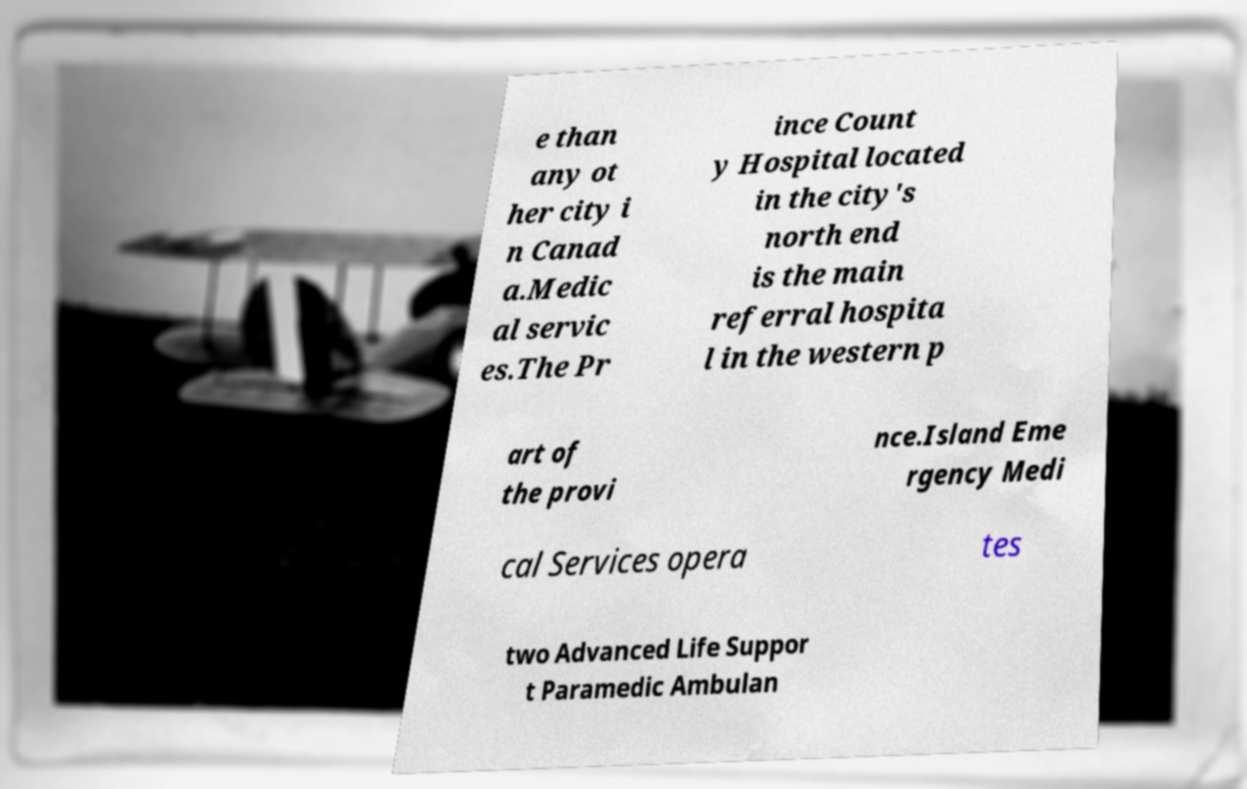Can you read and provide the text displayed in the image?This photo seems to have some interesting text. Can you extract and type it out for me? e than any ot her city i n Canad a.Medic al servic es.The Pr ince Count y Hospital located in the city's north end is the main referral hospita l in the western p art of the provi nce.Island Eme rgency Medi cal Services opera tes two Advanced Life Suppor t Paramedic Ambulan 